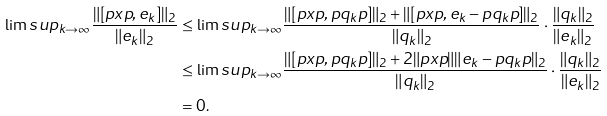<formula> <loc_0><loc_0><loc_500><loc_500>\lim s u p _ { k \rightarrow \infty } \frac { \| [ p x p , e _ { k } ] \| _ { 2 } } { \| e _ { k } \| _ { 2 } } & \leq \lim s u p _ { k \rightarrow \infty } \frac { \| [ p x p , p q _ { k } p ] \| _ { 2 } + \| [ p x p , e _ { k } - p q _ { k } p ] \| _ { 2 } } { \| q _ { k } \| _ { 2 } } \cdot \frac { \| q _ { k } \| _ { 2 } } { \| e _ { k } \| _ { 2 } } \\ & \leq \lim s u p _ { k \rightarrow \infty } \frac { \| [ p x p , p q _ { k } p ] \| _ { 2 } + 2 \| p x p \| \| e _ { k } - p q _ { k } p \| _ { 2 } } { \| q _ { k } \| _ { 2 } } \cdot \frac { \| q _ { k } \| _ { 2 } } { \| e _ { k } \| _ { 2 } } \\ & = 0 .</formula> 